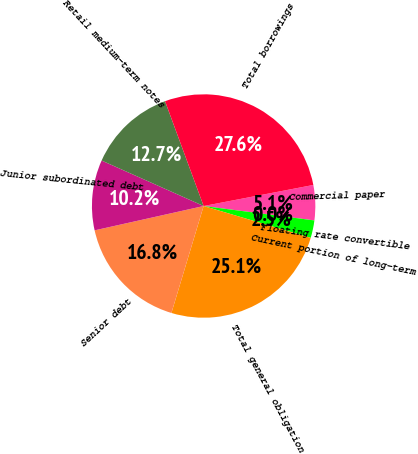Convert chart to OTSL. <chart><loc_0><loc_0><loc_500><loc_500><pie_chart><fcel>Commercial paper<fcel>Floating rate convertible<fcel>Current portion of long-term<fcel>Total general obligation<fcel>Senior debt<fcel>Junior subordinated debt<fcel>Retail medium-term notes<fcel>Total borrowings<nl><fcel>5.08%<fcel>0.0%<fcel>2.54%<fcel>25.06%<fcel>16.85%<fcel>10.17%<fcel>12.71%<fcel>27.6%<nl></chart> 